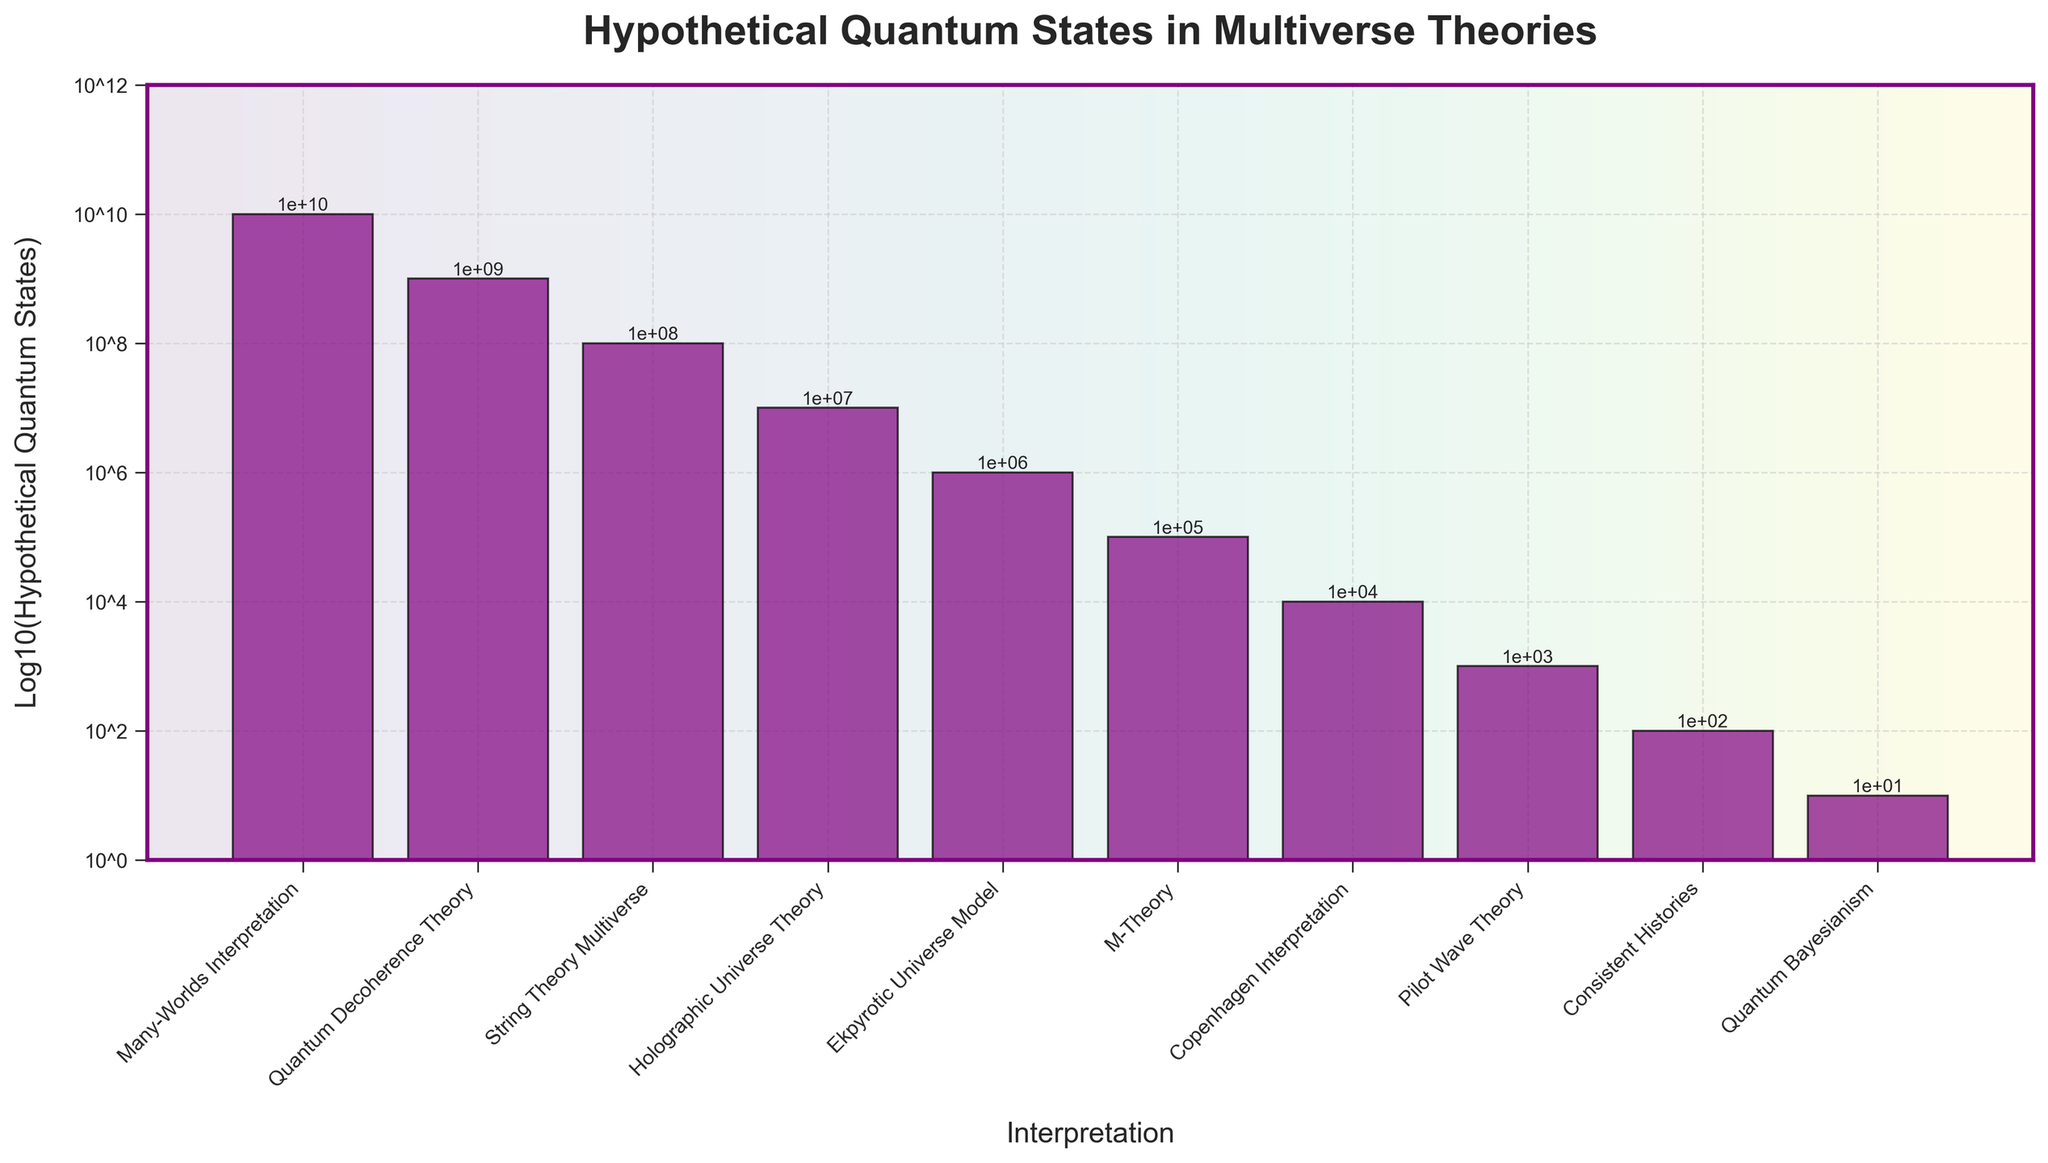What's the interpretation with the highest number of hypothetical quantum states? The bar chart shows that the Many-Worlds Interpretation has the highest bar, representing the highest number of hypothetical quantum states on the log10 scale. The exact value for Many-Worlds Interpretation is 10^10.
Answer: Many-Worlds Interpretation Which interpretation has the least number of hypothetical quantum states? The lowest bar on the chart represents the Quantum Bayesianism interpretation with a log10 value of 1, corresponding to 10 hypothetical quantum states.
Answer: Quantum Bayesianism How many interpretations have more hypothetical quantum states than M-Theory? M-Theory's bar corresponds to 10^5 states. Counting the bars that are higher, we have six interpretations: Many-Worlds Interpretation, Quantum Decoherence Theory, String Theory Multiverse, Holographic Universe Theory, Ekpyrotic Universe Model, and Copenhagen Interpretation.
Answer: 6 Compare the number of hypothetical quantum states between the Holographic Universe Theory and Quantum Decoherence Theory. Which one has more, and by how much? Holographic Universe Theory corresponds to 10^7 states, and Quantum Decoherence Theory corresponds to 10^9 states. Subtracting 10^7 from 10^9 gives us 99,000,000.
Answer: Quantum Decoherence Theory by 99,000,000 What's the combined logarithmic value of hypothetical quantum states for Many-Worlds Interpretation and Quantum Decoherence Theory? Many-Worlds Interpretation has a log value of 10, and Quantum Decoherence Theory has a log value of 9. The combined value (log10(10^10 + 10^9)) can be simplified to log10(1.1*10^10), approximately 10.04.
Answer: Approximately 10.04 Which interpretation has a hypothetical quantum state value closest to 1,000,000? Ekpyrotic Universe Model's bar sits exactly at the log value of 6, which corresponds to 1,000,000.
Answer: Ekpyrotic Universe Model What is the difference in the log10 value between M-Theory and Copenhagen Interpretation? From the chart, M-Theory has a log value of 5, and the Copenhagen Interpretation has a log value of 4. The difference is 5 - 4 = 1.
Answer: 1 Calculate the average logarithmic value of hypothetical quantum states across all interpretations. Summing the log10 values: 10 (Many-Worlds) + 9 (Decoherence) + 8 (String) + 7 (Holographic) + 6 (Ekpyrotic) + 5 (M-Theory) + 4 (Copenhagen) + 3 (Pilot Wave) + 2 (Consistent Histories) + 1 (Quantum Bayesianism) = 55. There are 10 interpretations, so the average is 55/10 = 5.5.
Answer: 5.5 